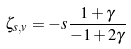<formula> <loc_0><loc_0><loc_500><loc_500>\zeta _ { s , v } = - s \frac { 1 + \gamma } { - 1 + 2 \gamma }</formula> 